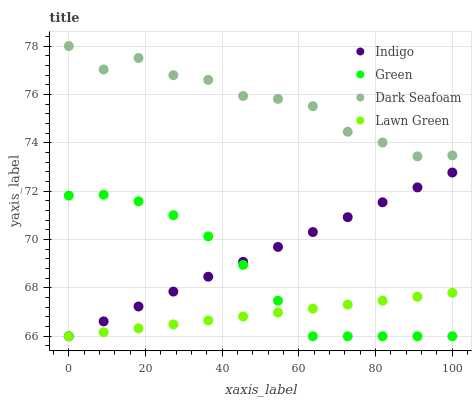Does Lawn Green have the minimum area under the curve?
Answer yes or no. Yes. Does Dark Seafoam have the maximum area under the curve?
Answer yes or no. Yes. Does Indigo have the minimum area under the curve?
Answer yes or no. No. Does Indigo have the maximum area under the curve?
Answer yes or no. No. Is Indigo the smoothest?
Answer yes or no. Yes. Is Dark Seafoam the roughest?
Answer yes or no. Yes. Is Dark Seafoam the smoothest?
Answer yes or no. No. Is Indigo the roughest?
Answer yes or no. No. Does Green have the lowest value?
Answer yes or no. Yes. Does Dark Seafoam have the lowest value?
Answer yes or no. No. Does Dark Seafoam have the highest value?
Answer yes or no. Yes. Does Indigo have the highest value?
Answer yes or no. No. Is Green less than Dark Seafoam?
Answer yes or no. Yes. Is Dark Seafoam greater than Indigo?
Answer yes or no. Yes. Does Indigo intersect Green?
Answer yes or no. Yes. Is Indigo less than Green?
Answer yes or no. No. Is Indigo greater than Green?
Answer yes or no. No. Does Green intersect Dark Seafoam?
Answer yes or no. No. 